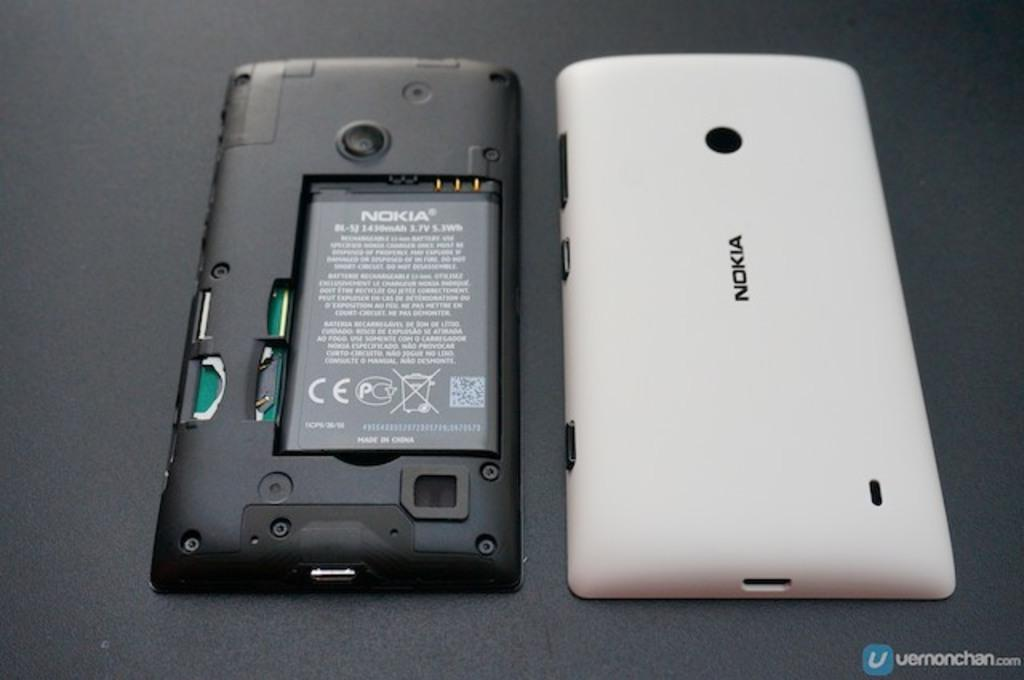<image>
Present a compact description of the photo's key features. the back side of a NOKIA phone with its battery exposed 